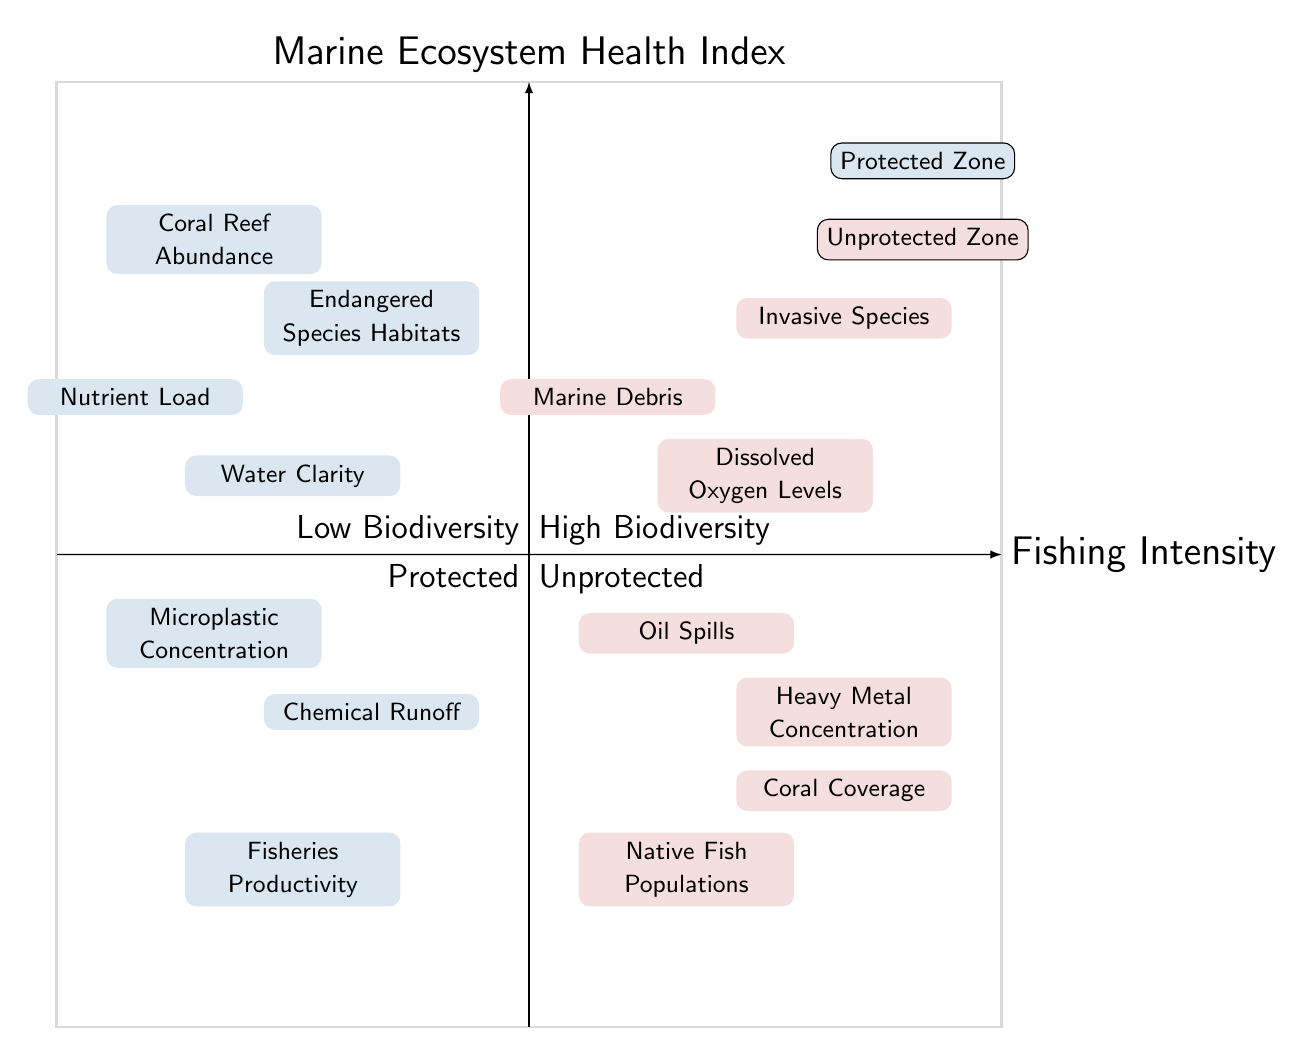What are the indicators of Biodiversity in Protected zones? The Protected zone has indicators of Biodiversity that include "Coral Reef Abundance" and "Endangered Species Habitats" under the High category, and "Fisheries Productivity" under the Low category.
Answer: Coral Reef Abundance, Endangered Species Habitats, Fisheries Productivity Which zone has High Pollution levels? The Unprotected zone displays High Pollution levels, indicated by "Oil Spills" and "Heavy Metal Concentration." The Protected zone has the same indicator but with different categories, noting the presence of "Microplastic Concentration" and "Chemical Runoff."
Answer: Unprotected How many indicators of Pollution are there in the Protected zone? In the Protected zone, there are four indicators of Pollution: "Microplastic Concentration," "Chemical Runoff," "Water Clarity," and "Nutrient Load." The pollution levels are classified into High and Low categories, with two indicators each.
Answer: Four Which indicator of Biodiversity is present in the Unprotected zone and classified as High? In the Unprotected zone, the indicator classified as High for Biodiversity is "Invasive Species." This is the only indicator listed under the High category for Biodiversity in this zone.
Answer: Invasive Species How does Fishing Intensity correspond with Biodiversity in Protected zones? In Protected zones, the Fishing Intensity appears lower or more restricted, allowing for higher Biodiversity levels, such as "Coral Reef Abundance" and "Endangered Species Habitats." Thus, increased protection leads to a beneficial relationship between Fishing Intensity and Biodiversity.
Answer: Higher Biodiversity with Lower Fishing Intensity What is the relationship between Fishing Intensity and Pollution indicators in Unprotected zones? In Unprotected zones, as Fishing Intensity likely increases, so do the Pollution indicators, such as "Oil Spills" and "Heavy Metal Concentration," which reflects negatively on the marine ecosystem health. This showcases an inverse relationship where more fishing leads to more pollution.
Answer: More Fishing leads to More Pollution Which indicator reflects Low Biodiversity in Unprotected zones? In the Unprotected zone, the indicators for Low Biodiversity include "Native Fish Populations" and "Coral Coverage." Both represent declining biodiversity levels likely due to increased fishing pressure and habitat degradation.
Answer: Native Fish Populations, Coral Coverage What is the Pollution level for "Water Clarity" in Protected zones? "Water Clarity" is classified under the Low Pollution levels in Protected zones, indicating better ecological health and lesser impact from pollution in these areas compared to their counterparts.
Answer: Low How many types of pollution indicators are represented in the Protected zone? The Protected zone has two types of pollution indicators, which are divided into High and Low, totaling four specific indicators: "Microplastic Concentration," "Chemical Runoff," "Water Clarity," and "Nutrient Load."
Answer: Four 